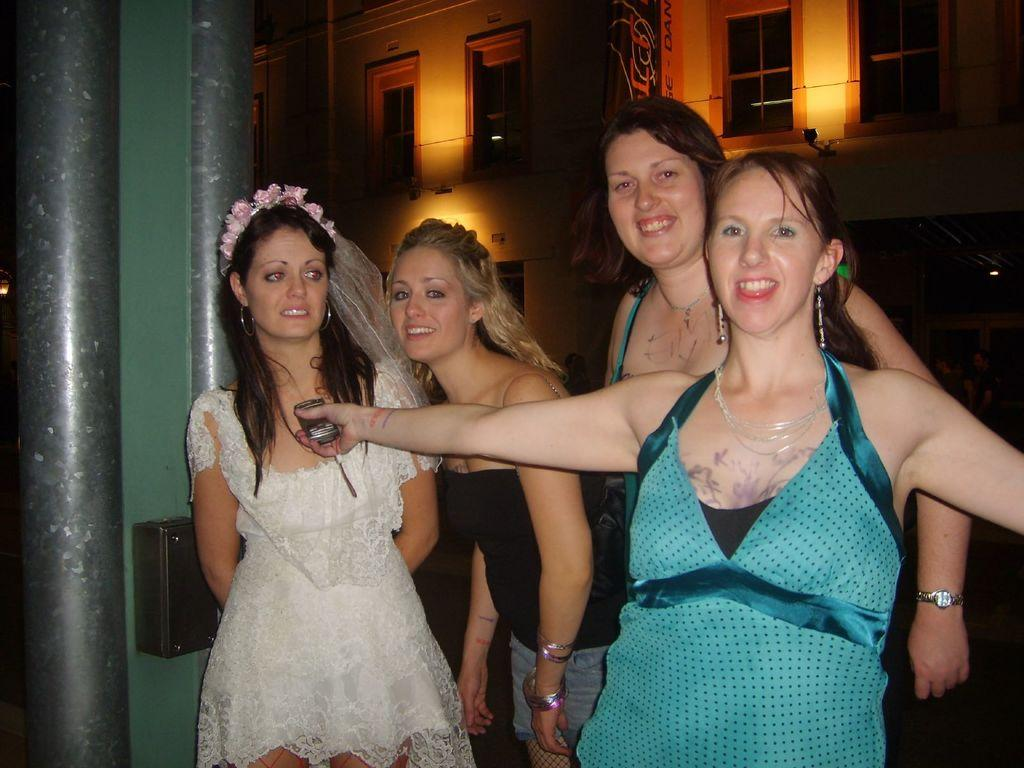Who is present in the image? There are girls in the image. What are the girls doing in the image? The girls are smiling. Can you describe the clothing of the girls in the image? One girl is wearing a blue top, and another girl is wearing a white frock. What can be seen in the background of the image? There is a building in the background of the image. Are there any cobwebs visible in the image? There is no mention of cobwebs in the provided facts, and therefore we cannot determine if any are present in the image. 